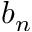Convert formula to latex. <formula><loc_0><loc_0><loc_500><loc_500>b _ { n }</formula> 